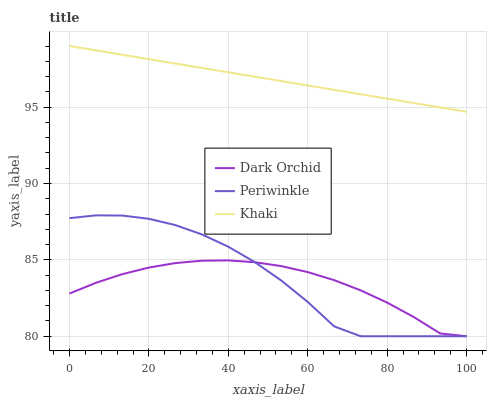Does Dark Orchid have the minimum area under the curve?
Answer yes or no. Yes. Does Khaki have the maximum area under the curve?
Answer yes or no. Yes. Does Periwinkle have the minimum area under the curve?
Answer yes or no. No. Does Periwinkle have the maximum area under the curve?
Answer yes or no. No. Is Khaki the smoothest?
Answer yes or no. Yes. Is Periwinkle the roughest?
Answer yes or no. Yes. Is Dark Orchid the smoothest?
Answer yes or no. No. Is Dark Orchid the roughest?
Answer yes or no. No. Does Periwinkle have the lowest value?
Answer yes or no. Yes. Does Khaki have the highest value?
Answer yes or no. Yes. Does Periwinkle have the highest value?
Answer yes or no. No. Is Dark Orchid less than Khaki?
Answer yes or no. Yes. Is Khaki greater than Periwinkle?
Answer yes or no. Yes. Does Periwinkle intersect Dark Orchid?
Answer yes or no. Yes. Is Periwinkle less than Dark Orchid?
Answer yes or no. No. Is Periwinkle greater than Dark Orchid?
Answer yes or no. No. Does Dark Orchid intersect Khaki?
Answer yes or no. No. 